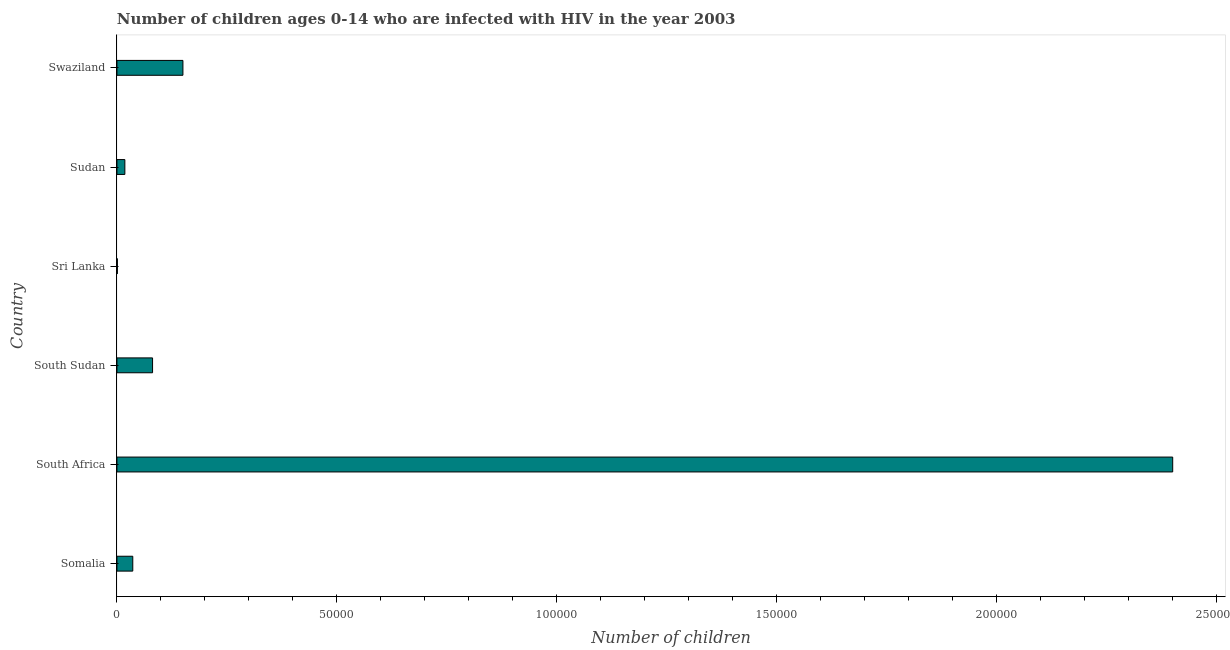What is the title of the graph?
Offer a terse response. Number of children ages 0-14 who are infected with HIV in the year 2003. What is the label or title of the X-axis?
Ensure brevity in your answer.  Number of children. What is the number of children living with hiv in Swaziland?
Provide a succinct answer. 1.50e+04. In which country was the number of children living with hiv maximum?
Keep it short and to the point. South Africa. In which country was the number of children living with hiv minimum?
Ensure brevity in your answer.  Sri Lanka. What is the sum of the number of children living with hiv?
Give a very brief answer. 2.69e+05. What is the difference between the number of children living with hiv in Sudan and Swaziland?
Make the answer very short. -1.32e+04. What is the average number of children living with hiv per country?
Keep it short and to the point. 4.48e+04. What is the median number of children living with hiv?
Provide a short and direct response. 5850. In how many countries, is the number of children living with hiv greater than 150000 ?
Offer a very short reply. 1. Is the number of children living with hiv in South Sudan less than that in Sudan?
Keep it short and to the point. No. Is the difference between the number of children living with hiv in Somalia and Sri Lanka greater than the difference between any two countries?
Your response must be concise. No. What is the difference between the highest and the second highest number of children living with hiv?
Give a very brief answer. 2.25e+05. Is the sum of the number of children living with hiv in South Africa and Swaziland greater than the maximum number of children living with hiv across all countries?
Give a very brief answer. Yes. What is the difference between the highest and the lowest number of children living with hiv?
Your answer should be very brief. 2.40e+05. In how many countries, is the number of children living with hiv greater than the average number of children living with hiv taken over all countries?
Keep it short and to the point. 1. How many countries are there in the graph?
Make the answer very short. 6. Are the values on the major ticks of X-axis written in scientific E-notation?
Your answer should be compact. No. What is the Number of children of Somalia?
Make the answer very short. 3600. What is the Number of children in South Sudan?
Provide a short and direct response. 8100. What is the Number of children of Sudan?
Ensure brevity in your answer.  1800. What is the Number of children in Swaziland?
Your answer should be very brief. 1.50e+04. What is the difference between the Number of children in Somalia and South Africa?
Provide a short and direct response. -2.36e+05. What is the difference between the Number of children in Somalia and South Sudan?
Offer a terse response. -4500. What is the difference between the Number of children in Somalia and Sri Lanka?
Your response must be concise. 3500. What is the difference between the Number of children in Somalia and Sudan?
Provide a succinct answer. 1800. What is the difference between the Number of children in Somalia and Swaziland?
Make the answer very short. -1.14e+04. What is the difference between the Number of children in South Africa and South Sudan?
Ensure brevity in your answer.  2.32e+05. What is the difference between the Number of children in South Africa and Sri Lanka?
Offer a very short reply. 2.40e+05. What is the difference between the Number of children in South Africa and Sudan?
Ensure brevity in your answer.  2.38e+05. What is the difference between the Number of children in South Africa and Swaziland?
Your response must be concise. 2.25e+05. What is the difference between the Number of children in South Sudan and Sri Lanka?
Offer a terse response. 8000. What is the difference between the Number of children in South Sudan and Sudan?
Ensure brevity in your answer.  6300. What is the difference between the Number of children in South Sudan and Swaziland?
Give a very brief answer. -6900. What is the difference between the Number of children in Sri Lanka and Sudan?
Your answer should be very brief. -1700. What is the difference between the Number of children in Sri Lanka and Swaziland?
Make the answer very short. -1.49e+04. What is the difference between the Number of children in Sudan and Swaziland?
Offer a very short reply. -1.32e+04. What is the ratio of the Number of children in Somalia to that in South Africa?
Keep it short and to the point. 0.01. What is the ratio of the Number of children in Somalia to that in South Sudan?
Provide a short and direct response. 0.44. What is the ratio of the Number of children in Somalia to that in Sudan?
Offer a very short reply. 2. What is the ratio of the Number of children in Somalia to that in Swaziland?
Provide a short and direct response. 0.24. What is the ratio of the Number of children in South Africa to that in South Sudan?
Provide a succinct answer. 29.63. What is the ratio of the Number of children in South Africa to that in Sri Lanka?
Offer a terse response. 2400. What is the ratio of the Number of children in South Africa to that in Sudan?
Ensure brevity in your answer.  133.33. What is the ratio of the Number of children in South Sudan to that in Sudan?
Your answer should be very brief. 4.5. What is the ratio of the Number of children in South Sudan to that in Swaziland?
Your answer should be very brief. 0.54. What is the ratio of the Number of children in Sri Lanka to that in Sudan?
Keep it short and to the point. 0.06. What is the ratio of the Number of children in Sri Lanka to that in Swaziland?
Your response must be concise. 0.01. What is the ratio of the Number of children in Sudan to that in Swaziland?
Ensure brevity in your answer.  0.12. 